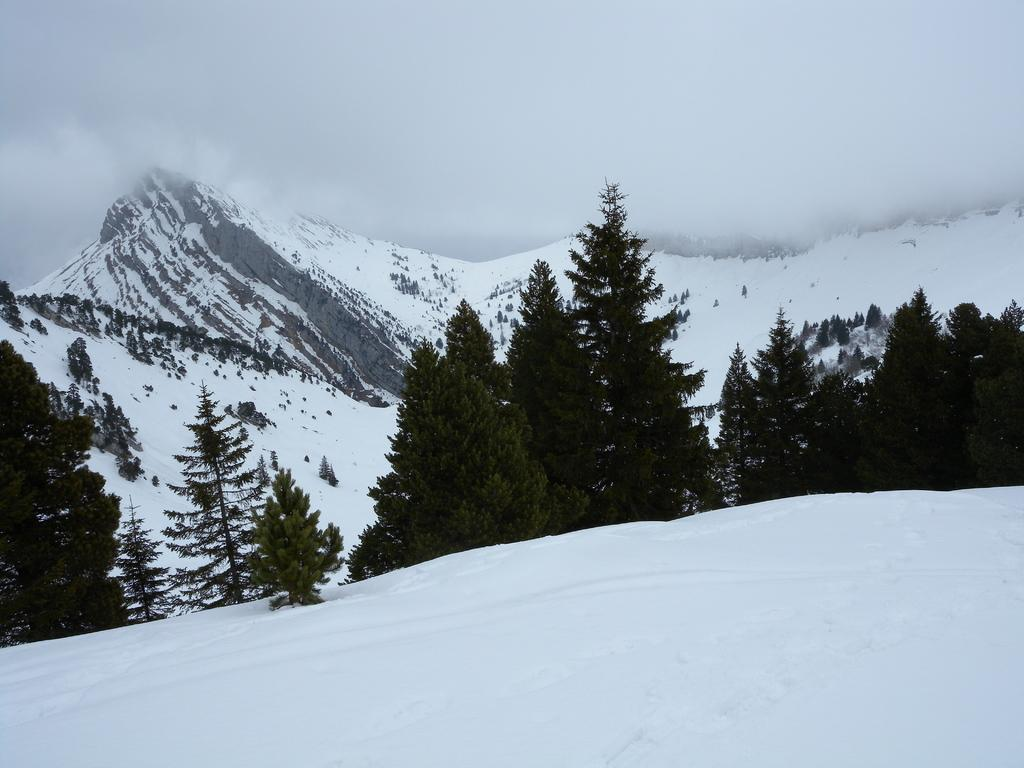What can be seen at the top of the image? The sky is visible at the top of the image. What type of geographical feature is present in the image? There are mountains in the image. What type of vegetation is present in the image? There are trees in the image. What is the ground covered with in the image? There is snow on the ground in the image. How many eyes can be seen on the trees in the image? There are no eyes present on the trees in the image; trees do not have eyes. What type of authority is depicted in the image? There is no authority figure present in the image; it features natural elements such as mountains, trees, and snow. 